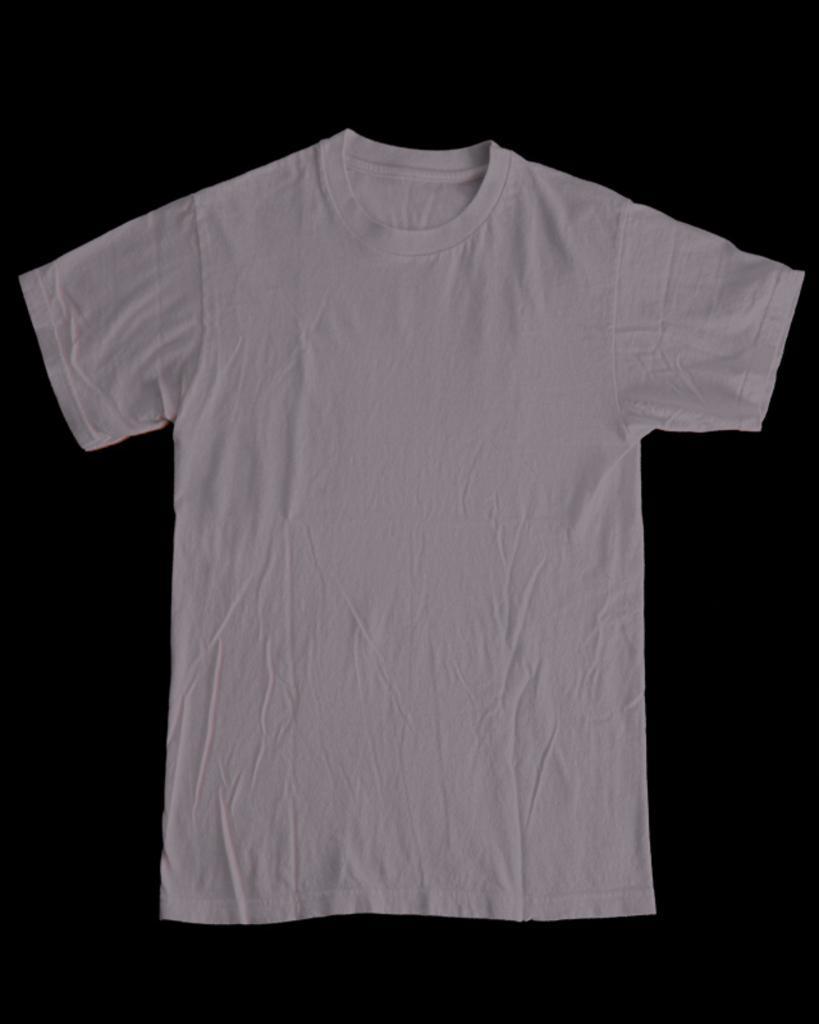Describe this image in one or two sentences. The picture consists of a white t-shirt on a black surface. 